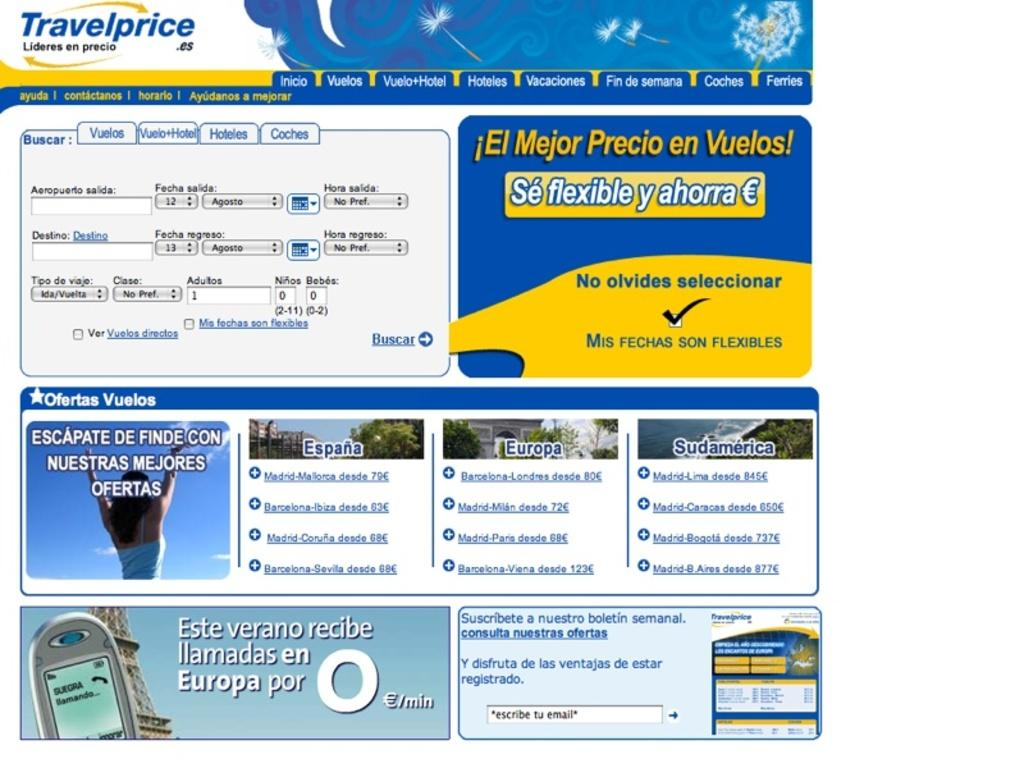What is present in the image? There is a poster in the image. What can be seen on the poster? The poster has images of a person and things, as well as texts. What is the color of the background on the poster? The background of the poster is white in color. Reasoning: Let' We start by identifying the main subject in the image, which is the poster. Then, we expand the conversation to include details about the poster's content, such as the images and texts. Finally, we describe the background color of the poster. Each question is designed to elicit a specific detail about the image that is known from the provided facts. Absurd Question/Answer: What type of land can be seen in the image? There is no land visible in the image; it only features a poster with images and texts. What kind of spade is being used by the person in the image? There is no person or spade present in the image. What type of holiday is being celebrated in the image? There is no indication of a holiday being celebrated in the image; it only features a poster with images and texts. 